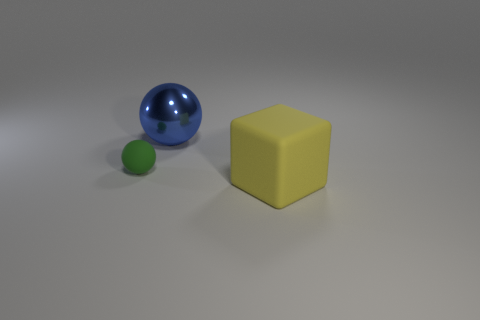Add 1 big yellow things. How many objects exist? 4 Subtract all cubes. How many objects are left? 2 Add 1 big cubes. How many big cubes exist? 2 Subtract 0 green blocks. How many objects are left? 3 Subtract all small blue shiny cylinders. Subtract all large yellow matte things. How many objects are left? 2 Add 2 small green objects. How many small green objects are left? 3 